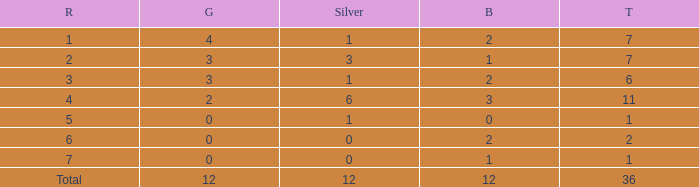What is the largest total for a team with fewer than 12 bronze, 1 silver and 0 gold medals? 1.0. 